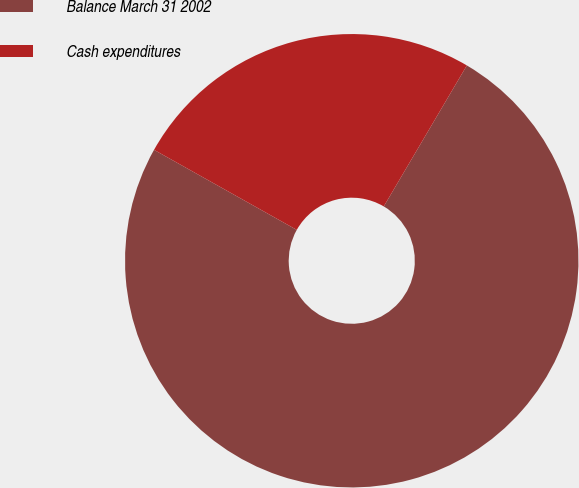<chart> <loc_0><loc_0><loc_500><loc_500><pie_chart><fcel>Balance March 31 2002<fcel>Cash expenditures<nl><fcel>74.66%<fcel>25.34%<nl></chart> 